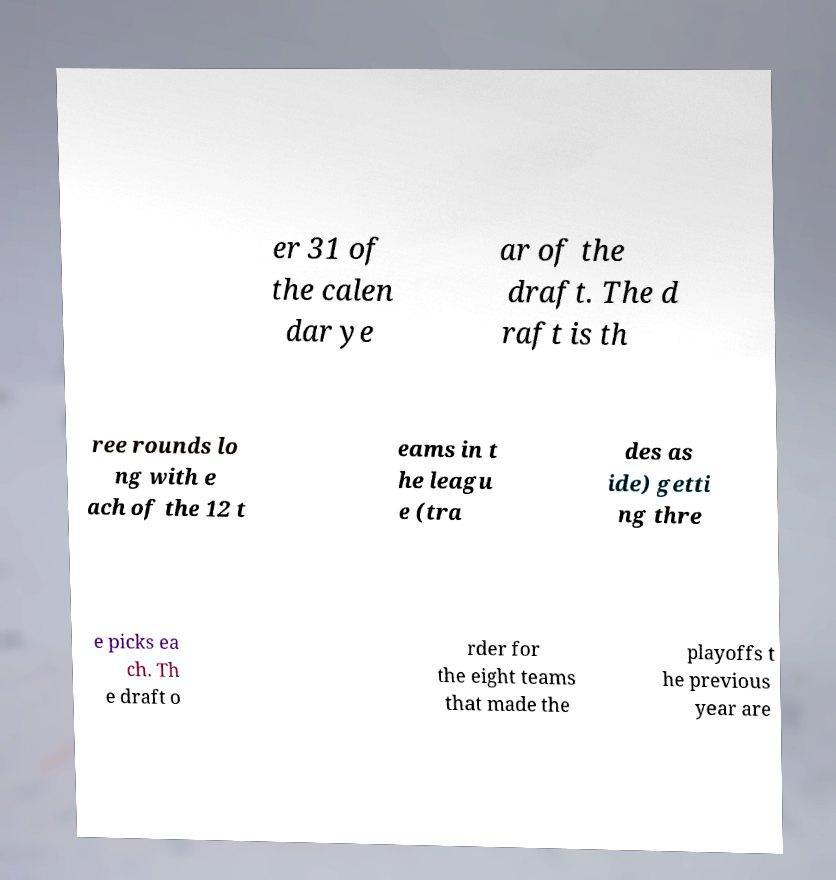Can you read and provide the text displayed in the image?This photo seems to have some interesting text. Can you extract and type it out for me? er 31 of the calen dar ye ar of the draft. The d raft is th ree rounds lo ng with e ach of the 12 t eams in t he leagu e (tra des as ide) getti ng thre e picks ea ch. Th e draft o rder for the eight teams that made the playoffs t he previous year are 